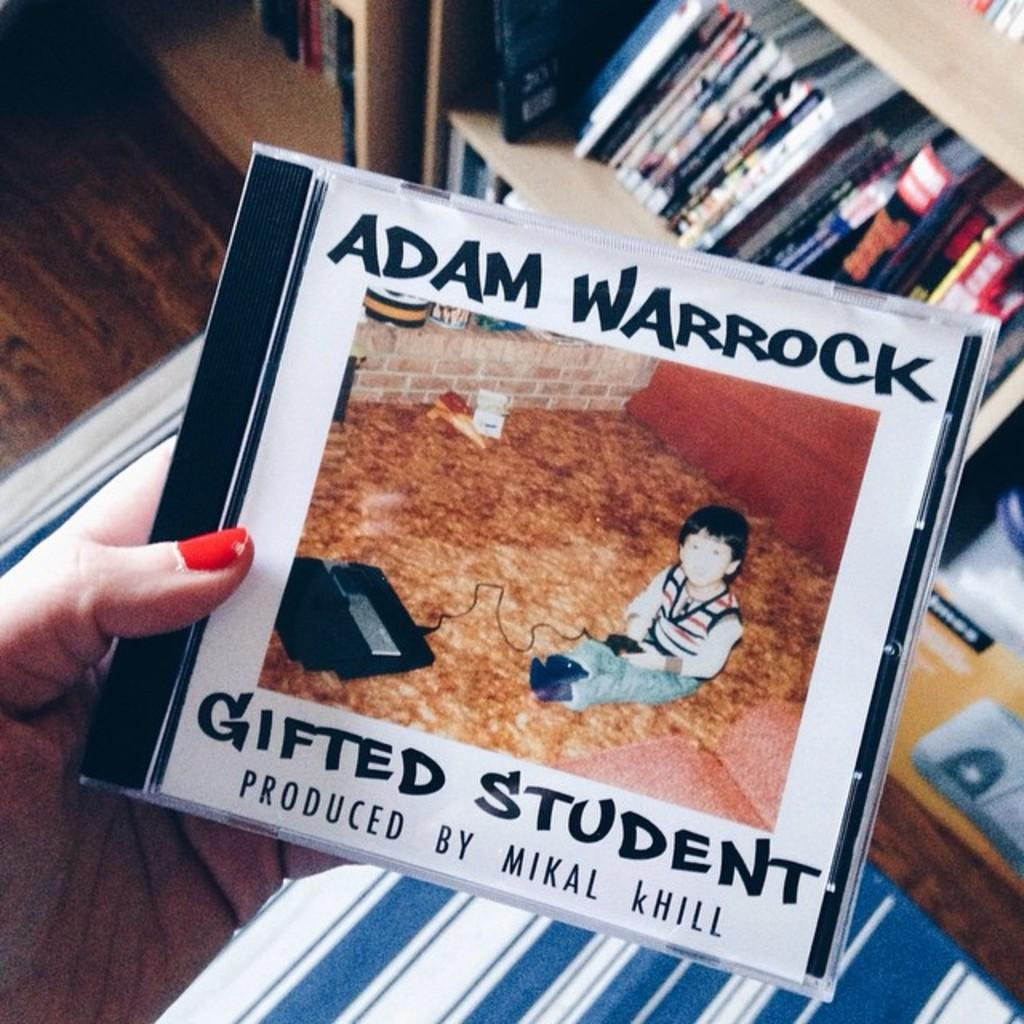<image>
Offer a succinct explanation of the picture presented. a cd by adam warrock called gifted student 